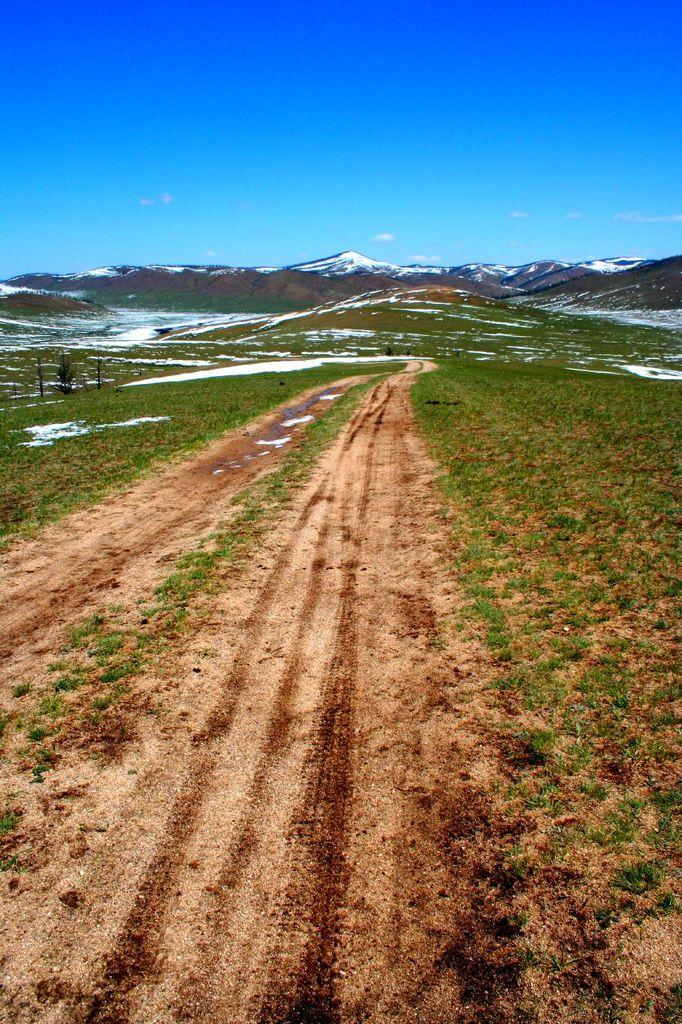What is the main feature of the image? There is a road in the image. What can be seen on both sides of the road? There is grass on both sides of the road. What is visible in the background of the image? There are mountains in the background of the image. What color is the sky in the image? The sky is visible at the top of the image and is blue in color. What type of dinner is being served in the image? There is no dinner present in the image; it features a road, grass, mountains, and a blue sky. How many companies are visible in the image? There are no companies visible in the image; it features a road, grass, mountains, and a blue sky. 